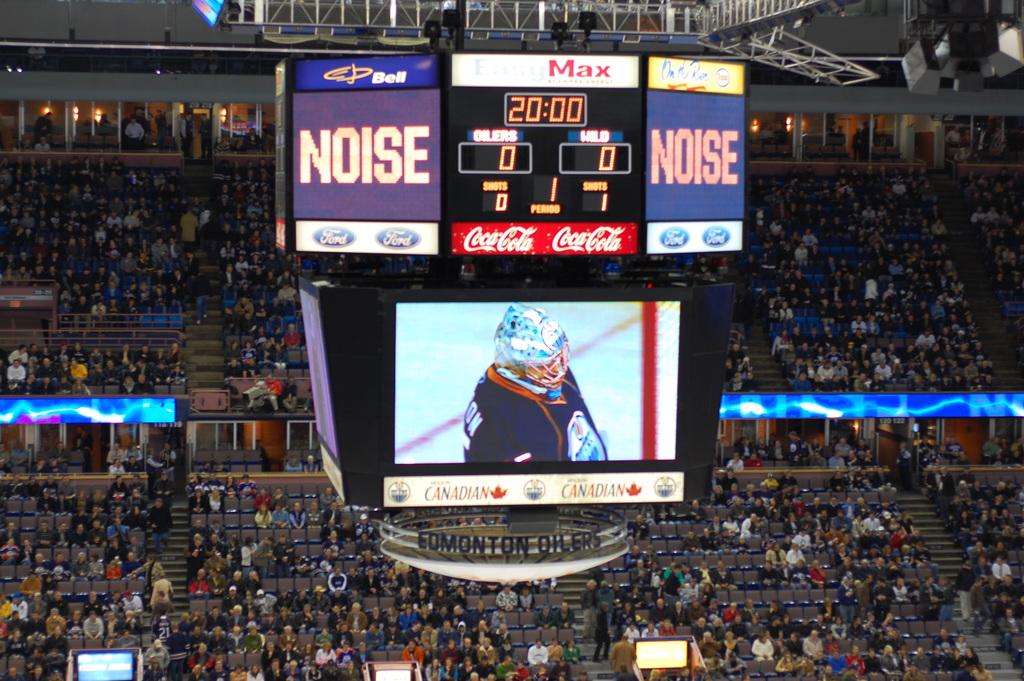Does coke sponsor this sporting event?
Your response must be concise. Yes. What´s the name on the red poster in the middle?
Offer a terse response. Coca cola. 